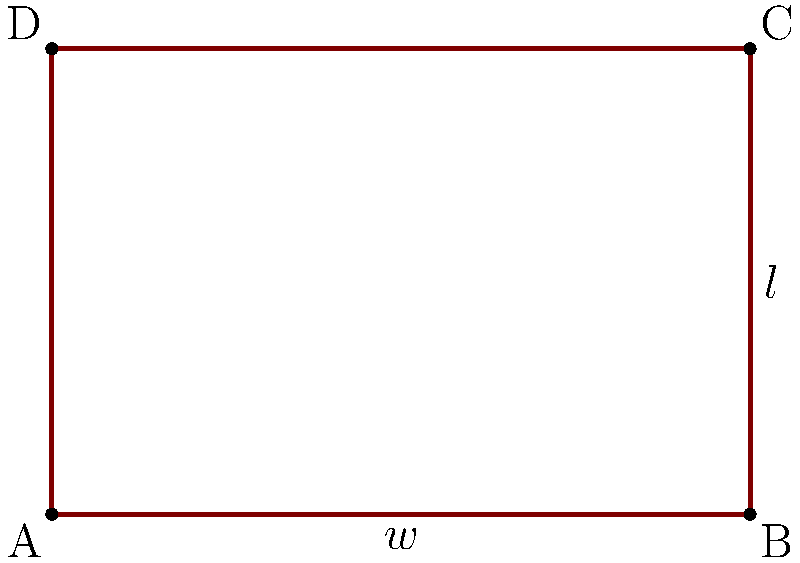You're planning a vegetable garden in your backyard and want to maximize its area. The garden will be rectangular, and you have 100 feet of fencing material to enclose it. What dimensions should you use for the length and width of the garden to achieve the maximum possible area? Let's approach this step-by-step:

1) Let $w$ be the width and $l$ be the length of the garden.

2) Given that the perimeter is fixed at 100 feet, we can write:
   $2w + 2l = 100$

3) Solving for $l$:
   $l = 50 - w$

4) The area $A$ of the garden is given by:
   $A = w * l = w(50 - w) = 50w - w^2$

5) To find the maximum area, we need to find where the derivative of $A$ with respect to $w$ is zero:
   $\frac{dA}{dw} = 50 - 2w$

6) Setting this equal to zero:
   $50 - 2w = 0$
   $2w = 50$
   $w = 25$

7) Since the second derivative $\frac{d^2A}{dw^2} = -2$ is negative, this critical point is a maximum.

8) With $w = 25$, we can find $l$:
   $l = 50 - 25 = 25$

Therefore, to maximize the area, the garden should be a square with both width and length equal to 25 feet.

9) The maximum area is:
   $A = 25 * 25 = 625$ square feet
Answer: 25 feet by 25 feet 